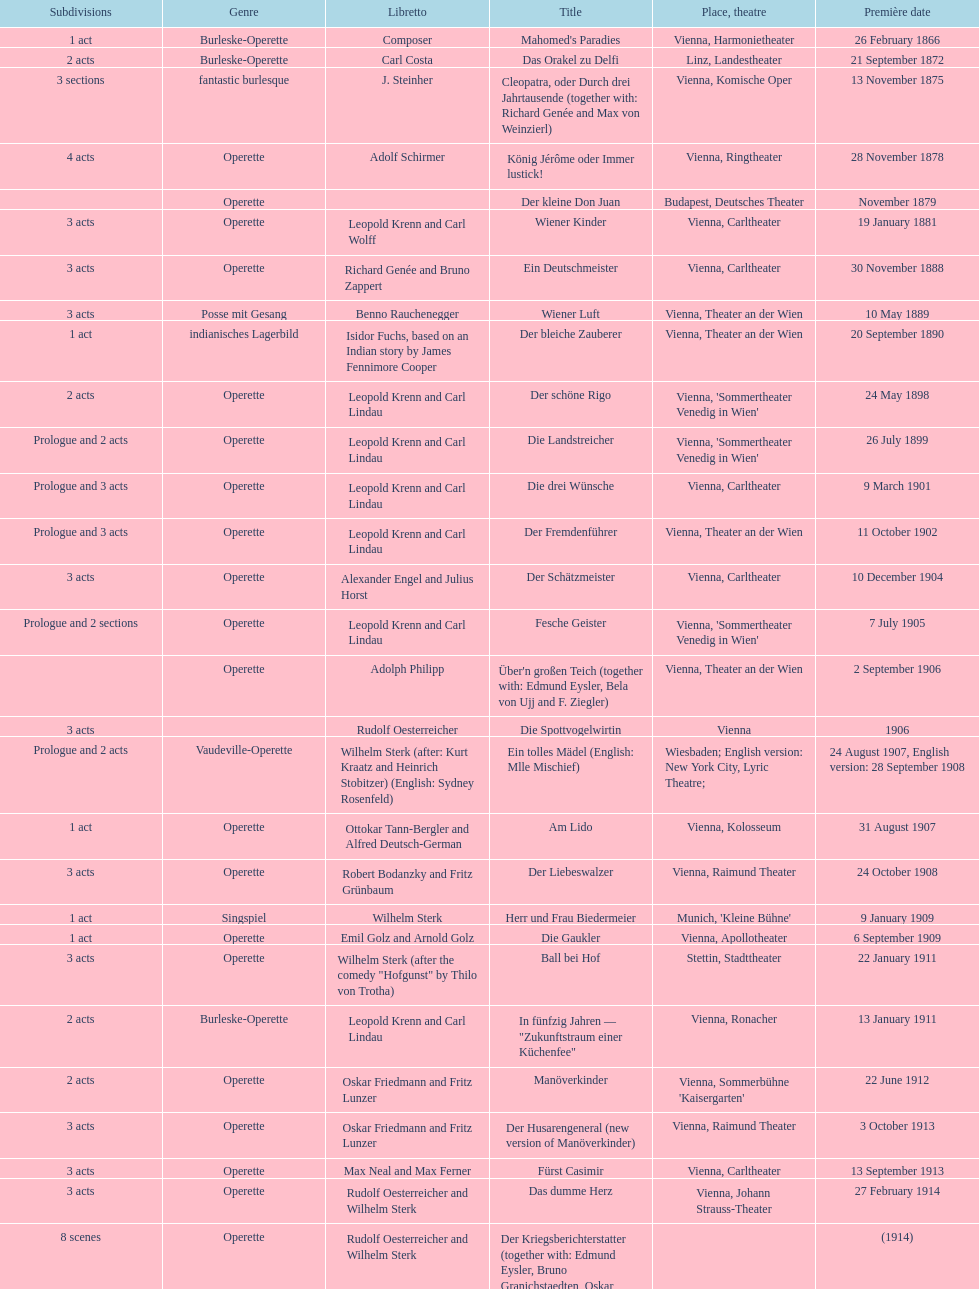Which type is predominantly displayed in this chart? Operette. 